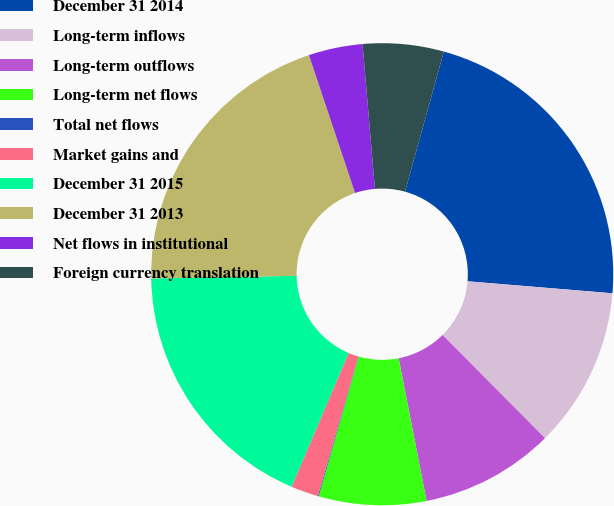Convert chart to OTSL. <chart><loc_0><loc_0><loc_500><loc_500><pie_chart><fcel>December 31 2014<fcel>Long-term inflows<fcel>Long-term outflows<fcel>Long-term net flows<fcel>Total net flows<fcel>Market gains and<fcel>December 31 2015<fcel>December 31 2013<fcel>Net flows in institutional<fcel>Foreign currency translation<nl><fcel>22.02%<fcel>11.24%<fcel>9.37%<fcel>7.51%<fcel>0.06%<fcel>1.92%<fcel>18.29%<fcel>20.16%<fcel>3.78%<fcel>5.65%<nl></chart> 